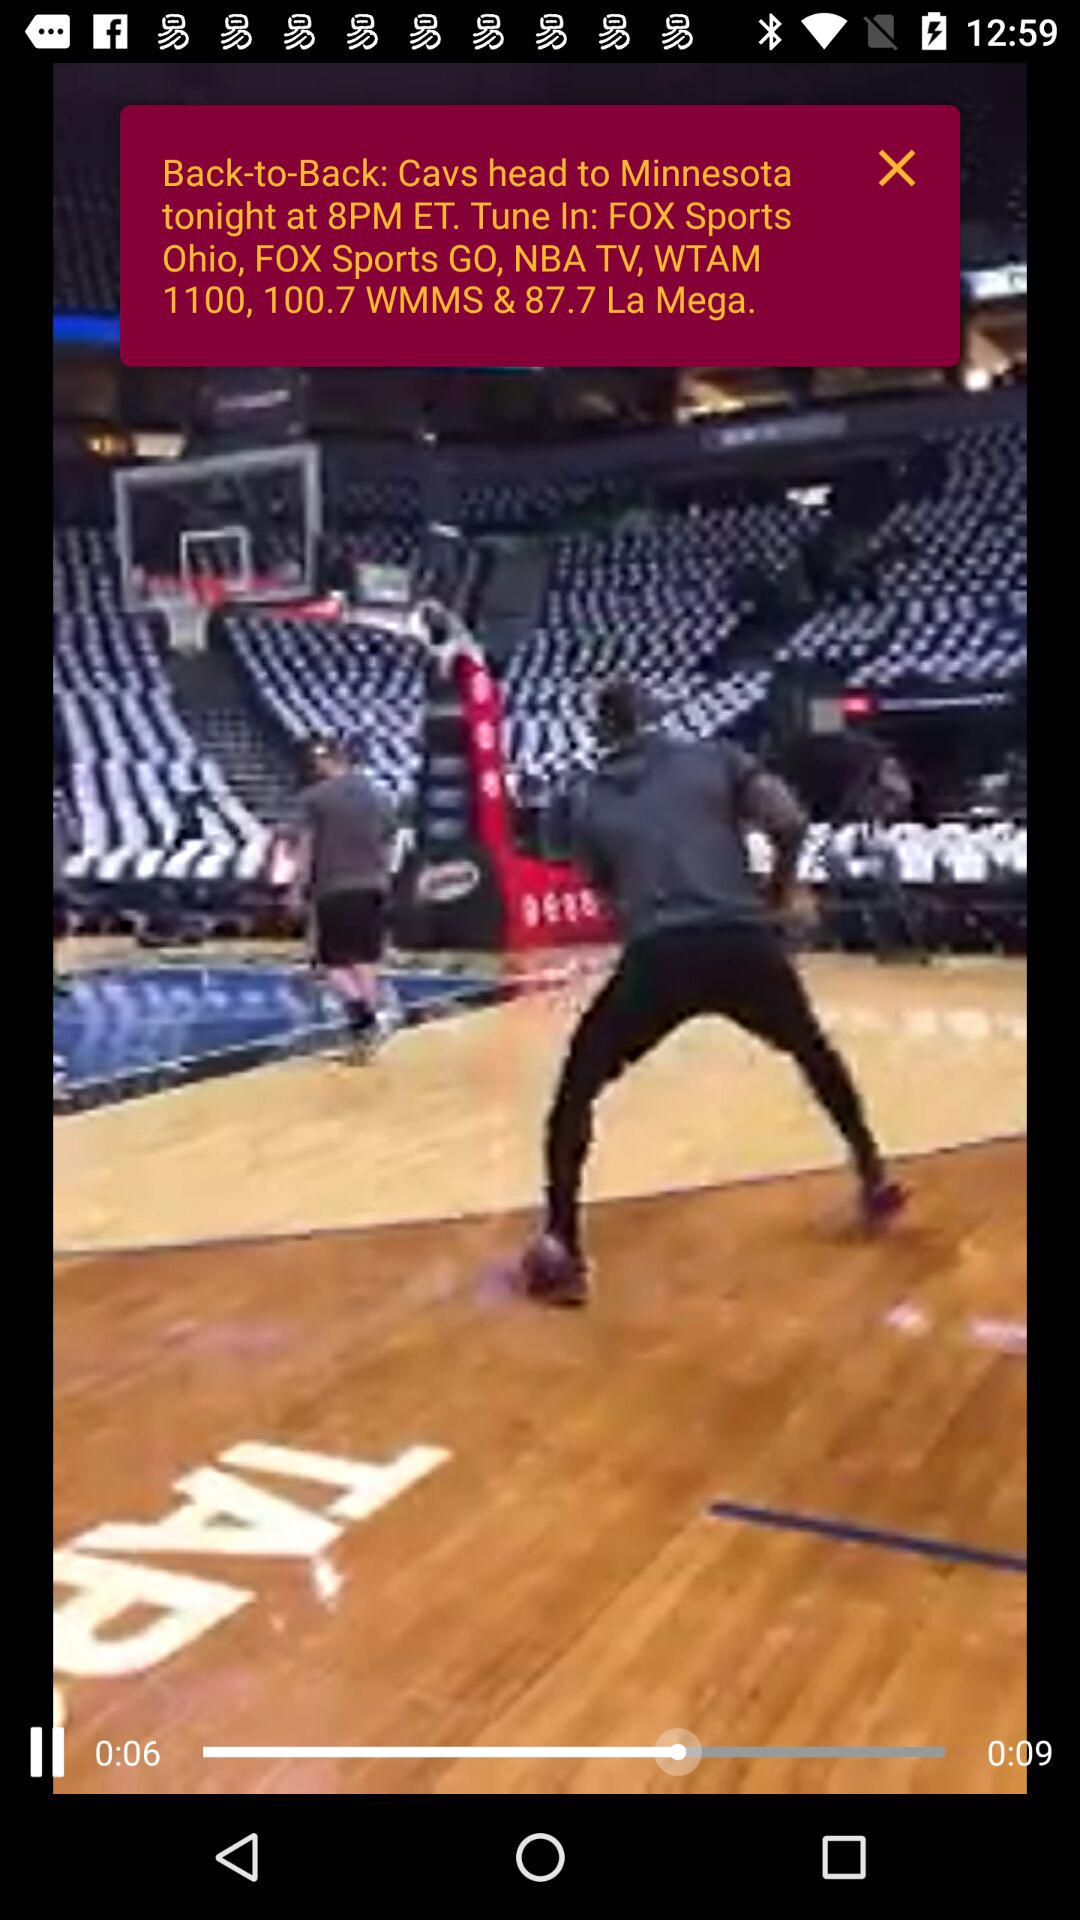What is the duration of the video? The duration is 0:09 seconds. 